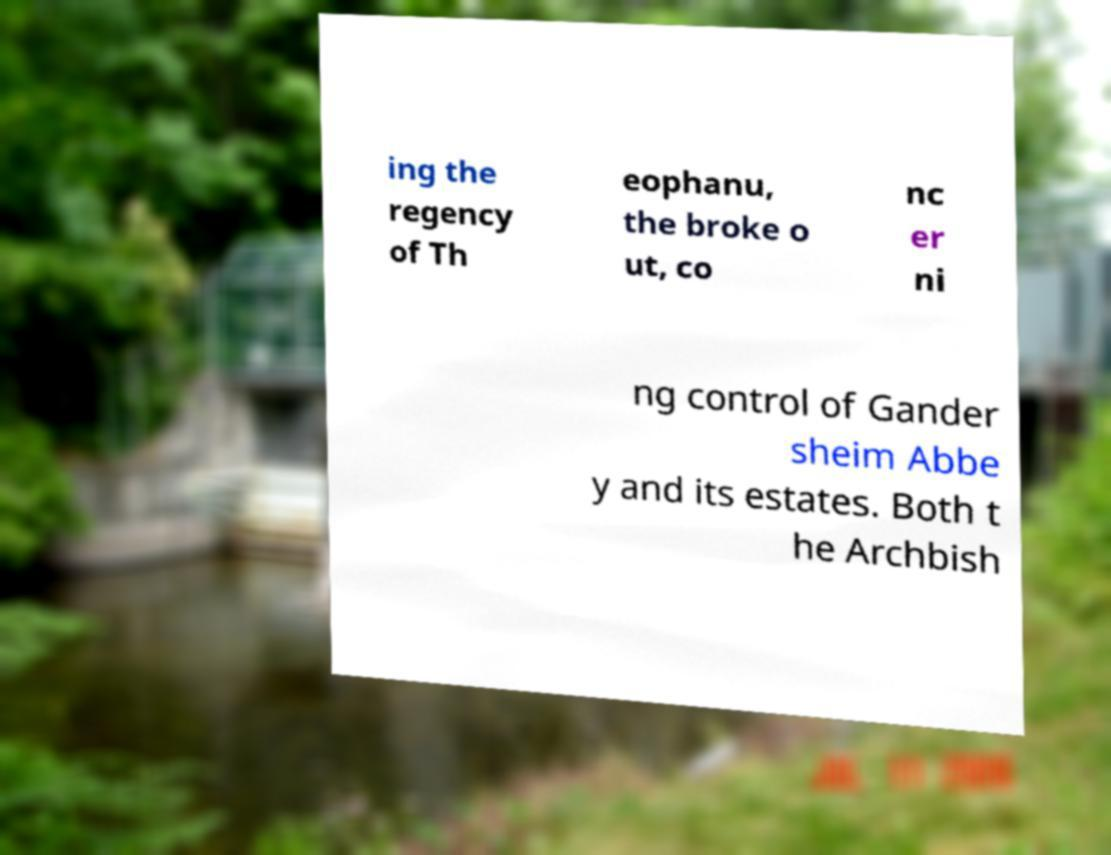What messages or text are displayed in this image? I need them in a readable, typed format. ing the regency of Th eophanu, the broke o ut, co nc er ni ng control of Gander sheim Abbe y and its estates. Both t he Archbish 